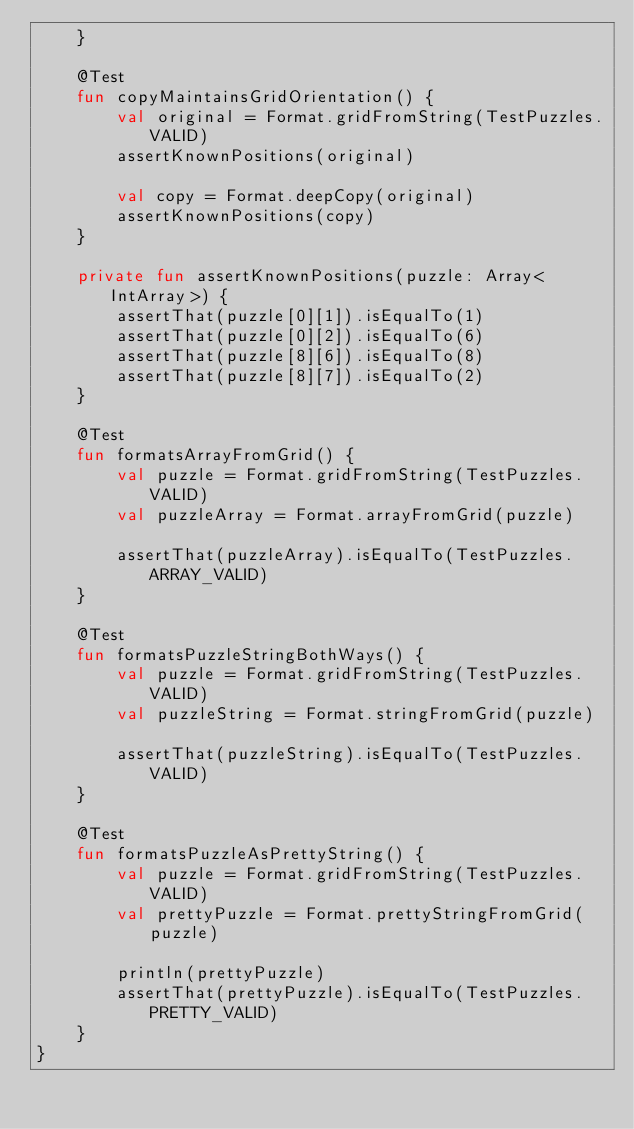<code> <loc_0><loc_0><loc_500><loc_500><_Kotlin_>    }

    @Test
    fun copyMaintainsGridOrientation() {
        val original = Format.gridFromString(TestPuzzles.VALID)
        assertKnownPositions(original)

        val copy = Format.deepCopy(original)
        assertKnownPositions(copy)
    }

    private fun assertKnownPositions(puzzle: Array<IntArray>) {
        assertThat(puzzle[0][1]).isEqualTo(1)
        assertThat(puzzle[0][2]).isEqualTo(6)
        assertThat(puzzle[8][6]).isEqualTo(8)
        assertThat(puzzle[8][7]).isEqualTo(2)
    }

    @Test
    fun formatsArrayFromGrid() {
        val puzzle = Format.gridFromString(TestPuzzles.VALID)
        val puzzleArray = Format.arrayFromGrid(puzzle)

        assertThat(puzzleArray).isEqualTo(TestPuzzles.ARRAY_VALID)
    }

    @Test
    fun formatsPuzzleStringBothWays() {
        val puzzle = Format.gridFromString(TestPuzzles.VALID)
        val puzzleString = Format.stringFromGrid(puzzle)

        assertThat(puzzleString).isEqualTo(TestPuzzles.VALID)
    }

    @Test
    fun formatsPuzzleAsPrettyString() {
        val puzzle = Format.gridFromString(TestPuzzles.VALID)
        val prettyPuzzle = Format.prettyStringFromGrid(puzzle)

        println(prettyPuzzle)
        assertThat(prettyPuzzle).isEqualTo(TestPuzzles.PRETTY_VALID)
    }
}
</code> 